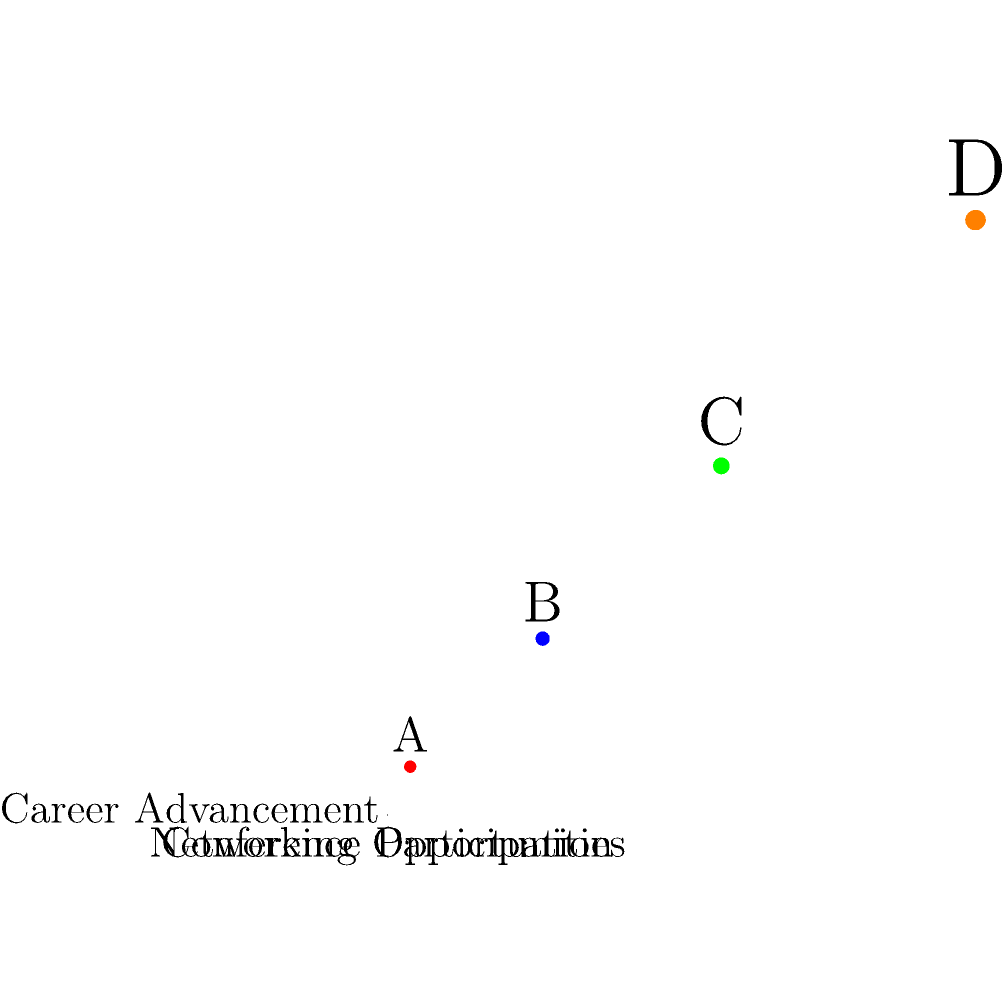In the 3D coordinate system shown, points A, B, C, and D represent different professionals' experiences with conferences. The x-axis represents conference participation, the y-axis represents networking opportunities, and the z-axis represents career advancement. Which point likely represents the professional with the most significant overall impact from conference attendance, and what can be inferred about the relationship between these variables? To answer this question, we need to analyze the position of each point in the 3D space:

1. Point A: (2,1,1) - Low in all three dimensions
2. Point B: (3,2,2) - Moderate in all three dimensions
3. Point C: (4,3,3) - High in all three dimensions
4. Point D: (5,4,4) - Highest in all three dimensions

Step 1: Identify the point with the highest overall impact
Point D has the highest values in all three dimensions, indicating the most conference participation, networking opportunities, and career advancement.

Step 2: Analyze the relationship between variables
As we move from point A to D, we observe that all three variables increase simultaneously. This suggests a positive correlation between conference participation, networking opportunities, and career advancement.

Step 3: Interpret the relationship
The diagonal pattern formed by the points (from A to D) implies that increased conference participation is associated with more networking opportunities, which in turn correlates with greater career advancement.

Step 4: Consider the implications for professional development
This visualization supports the idea that conference attendance can play a significant role in career growth by providing networking opportunities and potentially leading to career advancement.
Answer: Point D; positive correlation between conference participation, networking, and career advancement. 